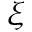<formula> <loc_0><loc_0><loc_500><loc_500>\xi</formula> 